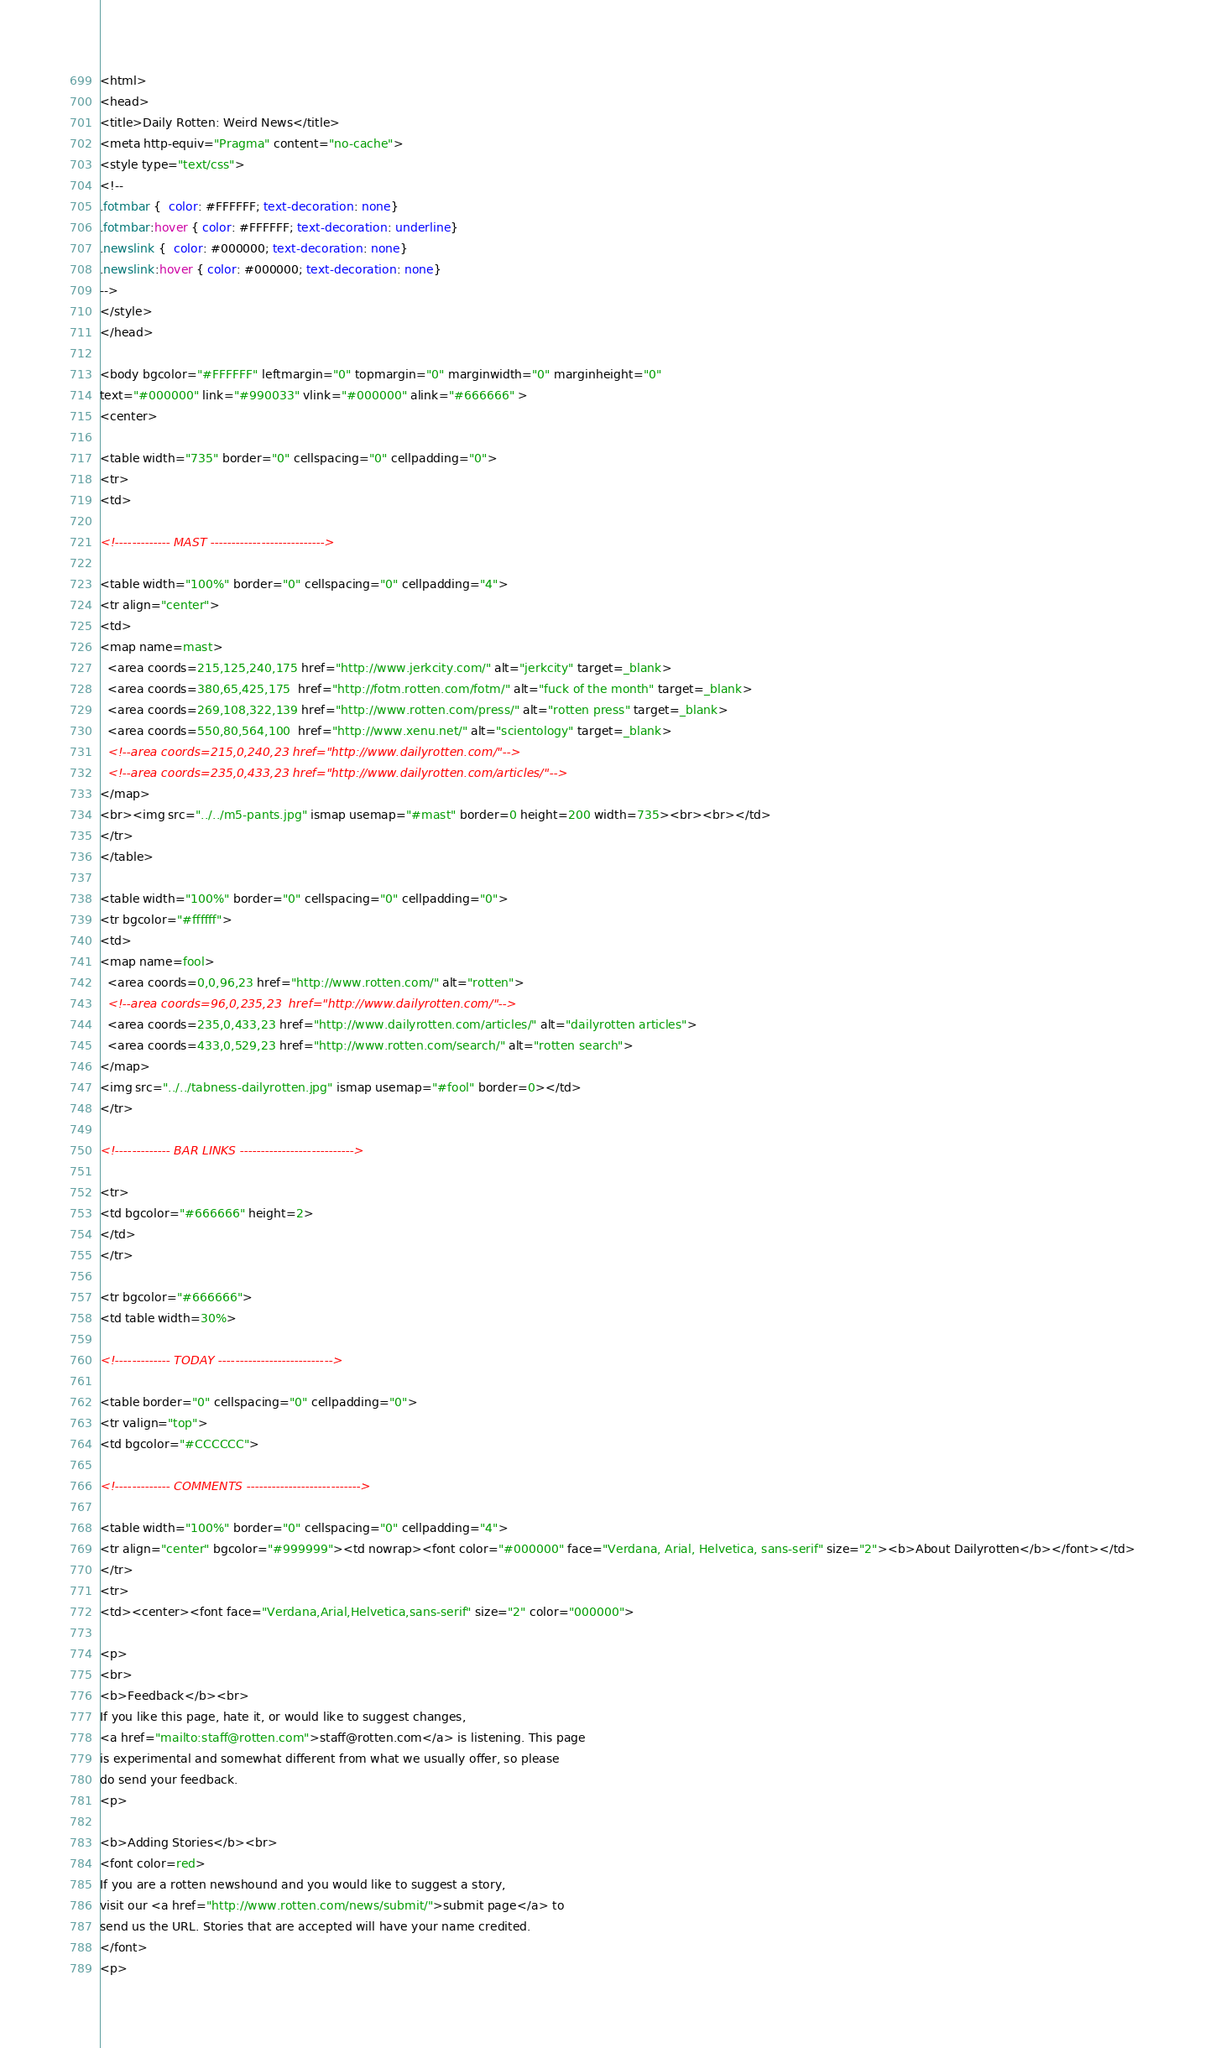Convert code to text. <code><loc_0><loc_0><loc_500><loc_500><_HTML_><html>
<head>
<title>Daily Rotten: Weird News</title>
<meta http-equiv="Pragma" content="no-cache">
<style type="text/css">
<!--
.fotmbar {  color: #FFFFFF; text-decoration: none}
.fotmbar:hover { color: #FFFFFF; text-decoration: underline}
.newslink {  color: #000000; text-decoration: none}
.newslink:hover { color: #000000; text-decoration: none}
-->
</style>
</head>

<body bgcolor="#FFFFFF" leftmargin="0" topmargin="0" marginwidth="0" marginheight="0" 
text="#000000" link="#990033" vlink="#000000" alink="#666666" >
<center>

<table width="735" border="0" cellspacing="0" cellpadding="0">
<tr>
<td>

<!------------- MAST --------------------------->

<table width="100%" border="0" cellspacing="0" cellpadding="4">
<tr align="center"> 
<td>
<map name=mast>
  <area coords=215,125,240,175 href="http://www.jerkcity.com/" alt="jerkcity" target=_blank>
  <area coords=380,65,425,175  href="http://fotm.rotten.com/fotm/" alt="fuck of the month" target=_blank>
  <area coords=269,108,322,139 href="http://www.rotten.com/press/" alt="rotten press" target=_blank>
  <area coords=550,80,564,100  href="http://www.xenu.net/" alt="scientology" target=_blank>
  <!--area coords=215,0,240,23 href="http://www.dailyrotten.com/"-->
  <!--area coords=235,0,433,23 href="http://www.dailyrotten.com/articles/"-->
</map>
<br><img src="../../m5-pants.jpg" ismap usemap="#mast" border=0 height=200 width=735><br><br></td>
</tr>
</table>

<table width="100%" border="0" cellspacing="0" cellpadding="0">
<tr bgcolor="#ffffff">
<td>
<map name=fool>
  <area coords=0,0,96,23 href="http://www.rotten.com/" alt="rotten">
  <!--area coords=96,0,235,23  href="http://www.dailyrotten.com/"-->
  <area coords=235,0,433,23 href="http://www.dailyrotten.com/articles/" alt="dailyrotten articles">
  <area coords=433,0,529,23 href="http://www.rotten.com/search/" alt="rotten search">
</map>
<img src="../../tabness-dailyrotten.jpg" ismap usemap="#fool" border=0></td>
</tr>

<!------------- BAR LINKS --------------------------->

<tr>
<td bgcolor="#666666" height=2>
</td>
</tr>

<tr bgcolor="#666666">
<td table width=30%>

<!------------- TODAY --------------------------->

<table border="0" cellspacing="0" cellpadding="0">
<tr valign="top"> 
<td bgcolor="#CCCCCC"> 

<!------------- COMMENTS --------------------------->

<table width="100%" border="0" cellspacing="0" cellpadding="4">
<tr align="center" bgcolor="#999999"><td nowrap><font color="#000000" face="Verdana, Arial, Helvetica, sans-serif" size="2"><b>About Dailyrotten</b></font></td>
</tr>
<tr> 
<td><center><font face="Verdana,Arial,Helvetica,sans-serif" size="2" color="000000">

<p>
<br>
<b>Feedback</b><br>
If you like this page, hate it, or would like to suggest changes,
<a href="mailto:staff@rotten.com">staff@rotten.com</a> is listening. This page
is experimental and somewhat different from what we usually offer, so please
do send your feedback. 
<p>

<b>Adding Stories</b><br>
<font color=red>
If you are a rotten newshound and you would like to suggest a story,
visit our <a href="http://www.rotten.com/news/submit/">submit page</a> to
send us the URL. Stories that are accepted will have your name credited.
</font>
<p>
</code> 